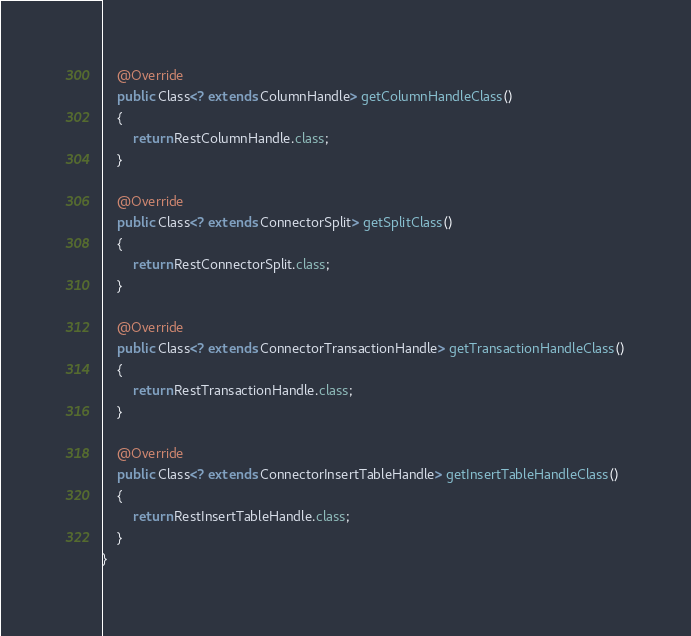<code> <loc_0><loc_0><loc_500><loc_500><_Java_>    @Override
    public Class<? extends ColumnHandle> getColumnHandleClass()
    {
        return RestColumnHandle.class;
    }

    @Override
    public Class<? extends ConnectorSplit> getSplitClass()
    {
        return RestConnectorSplit.class;
    }

    @Override
    public Class<? extends ConnectorTransactionHandle> getTransactionHandleClass()
    {
        return RestTransactionHandle.class;
    }

    @Override
    public Class<? extends ConnectorInsertTableHandle> getInsertTableHandleClass()
    {
        return RestInsertTableHandle.class;
    }
}
</code> 